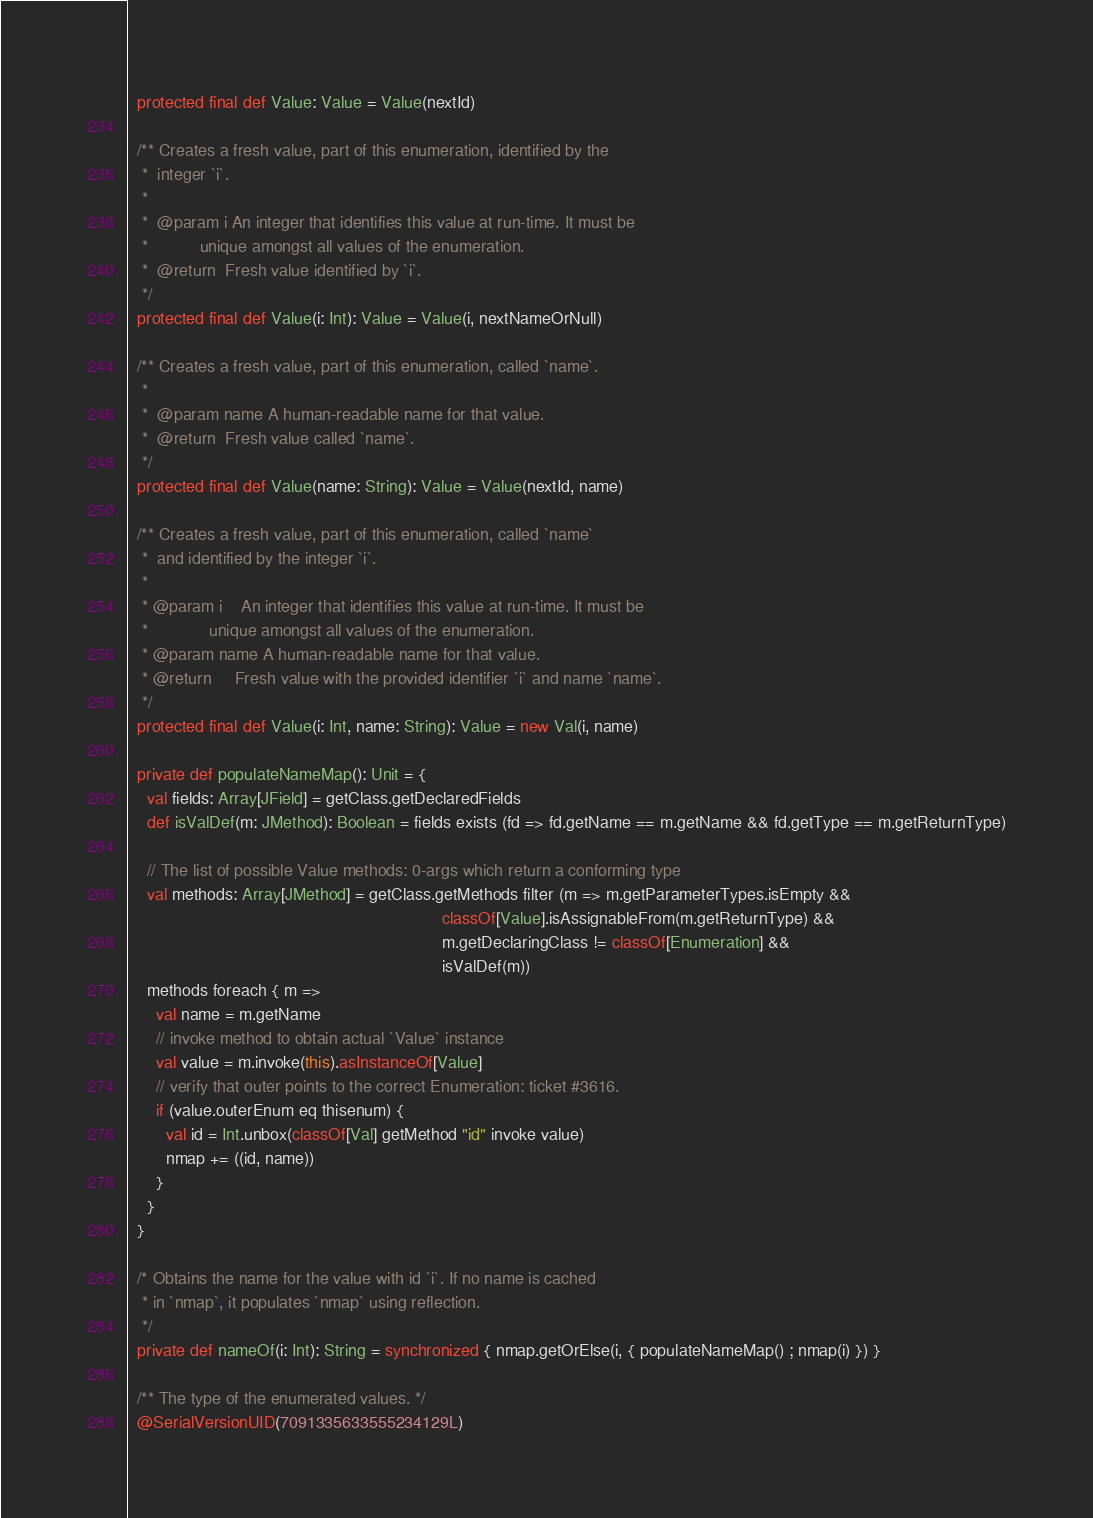Convert code to text. <code><loc_0><loc_0><loc_500><loc_500><_Scala_>  protected final def Value: Value = Value(nextId)

  /** Creates a fresh value, part of this enumeration, identified by the
   *  integer `i`.
   *
   *  @param i An integer that identifies this value at run-time. It must be
   *           unique amongst all values of the enumeration.
   *  @return  Fresh value identified by `i`.
   */
  protected final def Value(i: Int): Value = Value(i, nextNameOrNull)

  /** Creates a fresh value, part of this enumeration, called `name`.
   *
   *  @param name A human-readable name for that value.
   *  @return  Fresh value called `name`.
   */
  protected final def Value(name: String): Value = Value(nextId, name)

  /** Creates a fresh value, part of this enumeration, called `name`
   *  and identified by the integer `i`.
   *
   * @param i    An integer that identifies this value at run-time. It must be
   *             unique amongst all values of the enumeration.
   * @param name A human-readable name for that value.
   * @return     Fresh value with the provided identifier `i` and name `name`.
   */
  protected final def Value(i: Int, name: String): Value = new Val(i, name)

  private def populateNameMap(): Unit = {
    val fields: Array[JField] = getClass.getDeclaredFields
    def isValDef(m: JMethod): Boolean = fields exists (fd => fd.getName == m.getName && fd.getType == m.getReturnType)

    // The list of possible Value methods: 0-args which return a conforming type
    val methods: Array[JMethod] = getClass.getMethods filter (m => m.getParameterTypes.isEmpty &&
                                                                   classOf[Value].isAssignableFrom(m.getReturnType) &&
                                                                   m.getDeclaringClass != classOf[Enumeration] &&
                                                                   isValDef(m))
    methods foreach { m =>
      val name = m.getName
      // invoke method to obtain actual `Value` instance
      val value = m.invoke(this).asInstanceOf[Value]
      // verify that outer points to the correct Enumeration: ticket #3616.
      if (value.outerEnum eq thisenum) {
        val id = Int.unbox(classOf[Val] getMethod "id" invoke value)
        nmap += ((id, name))
      }
    }
  }

  /* Obtains the name for the value with id `i`. If no name is cached
   * in `nmap`, it populates `nmap` using reflection.
   */
  private def nameOf(i: Int): String = synchronized { nmap.getOrElse(i, { populateNameMap() ; nmap(i) }) }

  /** The type of the enumerated values. */
  @SerialVersionUID(7091335633555234129L)</code> 